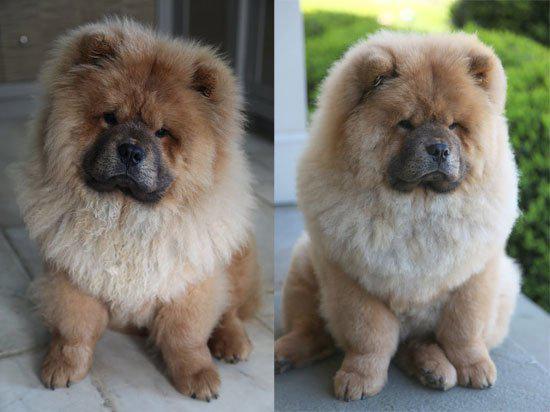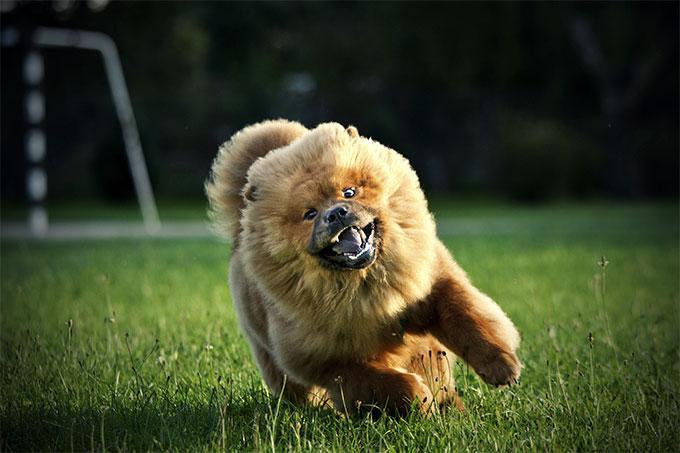The first image is the image on the left, the second image is the image on the right. For the images displayed, is the sentence "There are two dogs shown in total." factually correct? Answer yes or no. No. The first image is the image on the left, the second image is the image on the right. Assess this claim about the two images: "At least three dogs are shown, with only one in a grassy area.". Correct or not? Answer yes or no. Yes. 